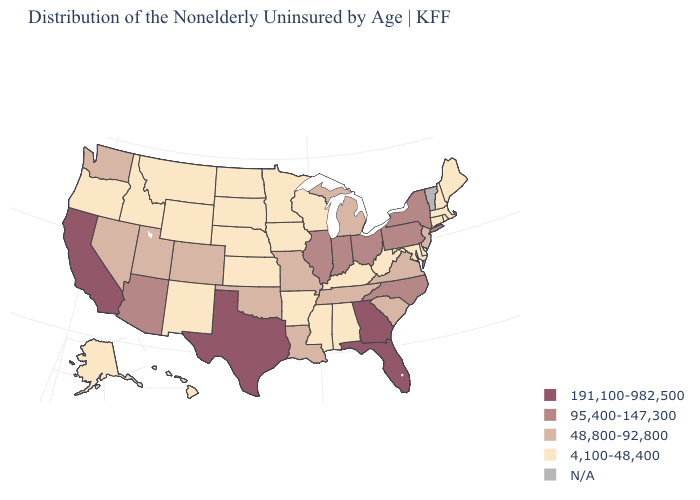Does the map have missing data?
Quick response, please. Yes. What is the value of Michigan?
Write a very short answer. 48,800-92,800. What is the highest value in the MidWest ?
Short answer required. 95,400-147,300. Name the states that have a value in the range 95,400-147,300?
Give a very brief answer. Arizona, Illinois, Indiana, New York, North Carolina, Ohio, Pennsylvania. What is the value of Ohio?
Be succinct. 95,400-147,300. Among the states that border Maine , which have the highest value?
Answer briefly. New Hampshire. What is the highest value in states that border Washington?
Quick response, please. 4,100-48,400. Does the first symbol in the legend represent the smallest category?
Short answer required. No. Does the map have missing data?
Quick response, please. Yes. What is the value of Illinois?
Be succinct. 95,400-147,300. Does the map have missing data?
Give a very brief answer. Yes. What is the highest value in the USA?
Short answer required. 191,100-982,500. Which states have the highest value in the USA?
Be succinct. California, Florida, Georgia, Texas. Among the states that border New York , which have the lowest value?
Keep it brief. Connecticut, Massachusetts. 